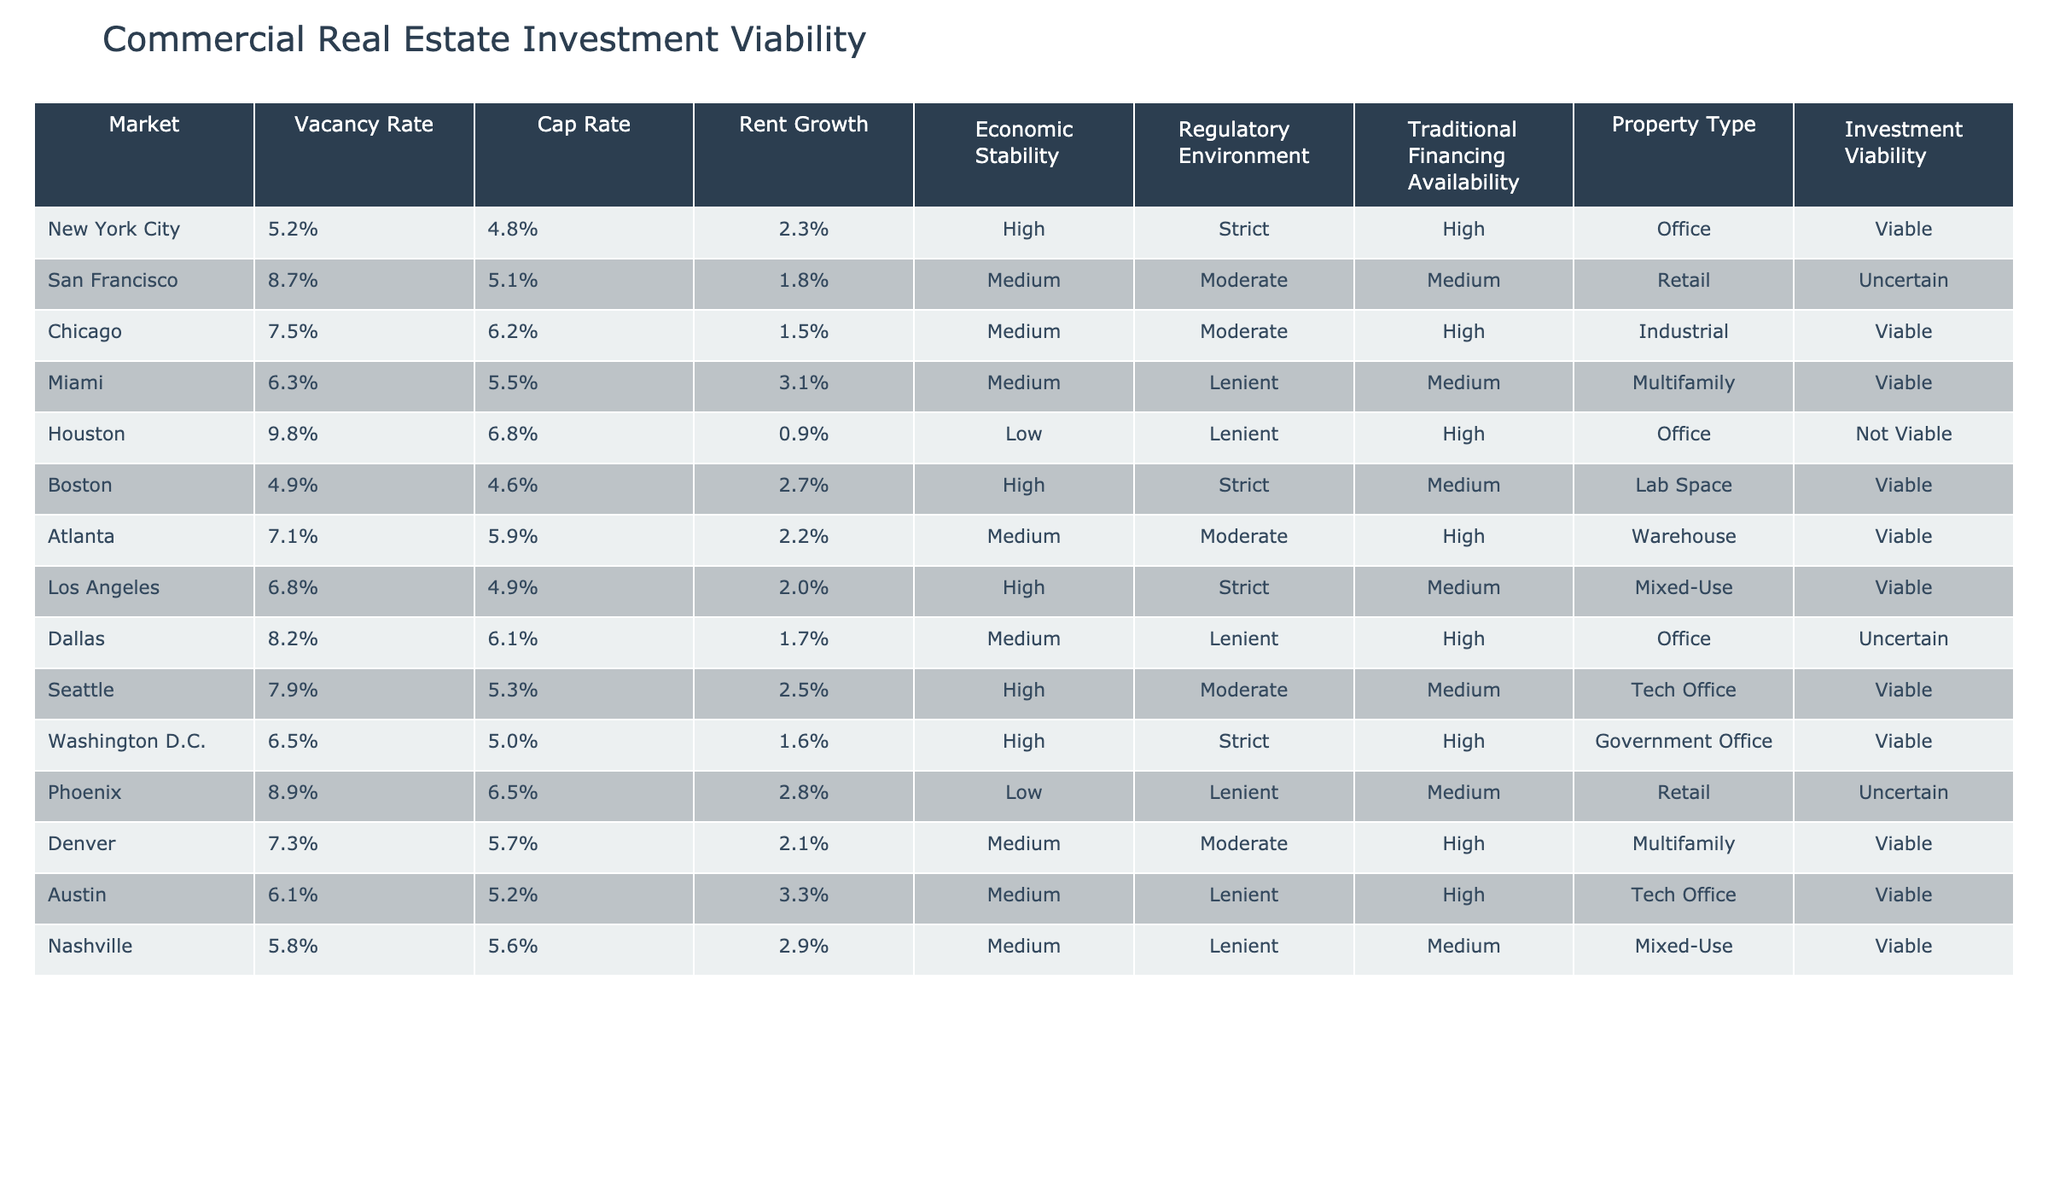What is the cap rate for New York City? The table lists the cap rate for New York City under the "Cap Rate" column. It states it is 4.8%.
Answer: 4.8% How many markets have a vacancy rate lower than 6%? By reviewing the "Vacancy Rate" column, only New York City (5.2%), Miami (6.3%), and Boston (4.9%) have rates lower than 6%. This means there are 3 markets.
Answer: 3 Is the investment viability for Phoenix classified as viable? According to the table, the investment viability for Phoenix is labeled as "Uncertain" under the "Investment Viability" column, which means it is not classified as viable.
Answer: No Which property type in Chicago has the highest cap rate and what is that cap rate? In the table, Chicago is associated with the Industrial property type and has a cap rate of 6.2%. Comparing this with other cities' property types, Chicago has one of the highest rates listed.
Answer: 6.2% What is the difference in rent growth between Miami and Austin? Miami has a rent growth of 3.1% while Austin has a rent growth of 3.3%. The difference is calculated by subtracting Miami's rent growth from Austin's: 3.3% - 3.1% = 0.2%.
Answer: 0.2% In how many markets is the regulatory environment classified as lenient? Reviewing the "Regulatory Environment" column, the markets with a lenient classification are Houston, Miami, Denver, Austin, and Nashville, totaling 5 markets.
Answer: 5 Does any market have a high economic stability but is classified as not viable? Looking at the table, Houston has a low economic stability and is classified as "Not Viable," whereas all other markets with high economic stability are classified as viable. Therefore, the answer is no.
Answer: No Which market has the highest vacancy rate, and what is both the vacancy rate and investment viability for that market? Upon inspection of the "Vacancy Rate" column, Houston has the highest vacancy rate at 9.8%. It is classified as "Not Viable" under the "Investment Viability" column.
Answer: 9.8%, Not Viable What is the average cap rate of the markets with viable investment classifications? To find the average cap rate for viable markets, we take the cap rates for New York City (4.8%), Chicago (6.2%), Miami (5.5%), Boston (4.6%), Atlanta (5.9%), Los Angeles (4.9%), Seattle (5.3%), Washington D.C. (5.0%), Denver (5.7%), Austin (5.2%), and Nashville (5.6%). The sum of these cap rates is 58.7% and there are 11 viable markets. Therefore, the average cap rate is calculated as follows: 58.7% / 11 = 5.34%.
Answer: 5.34% 